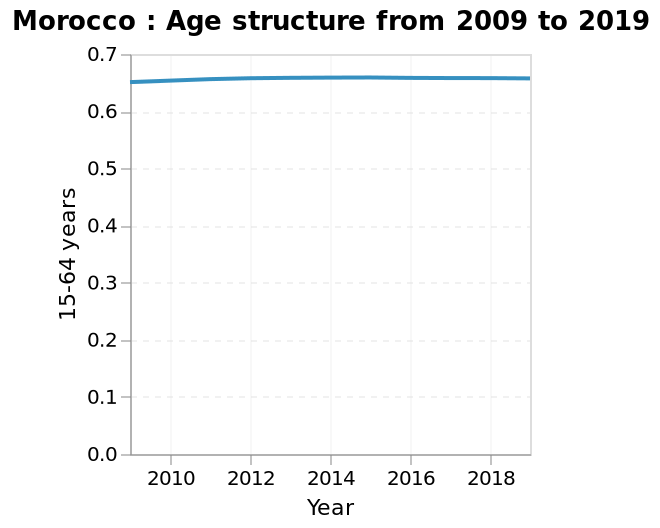<image>
How has the age structure in Morocco changed over time?  The age structure in Morocco has shown little change over the last decade, remaining at approximately 0.65. please summary the statistics and relations of the chart Morocco age structure has remained level in the last decade hovering around 0.65. What is the specific value of the age structure in Morocco?  The age structure in Morocco has been around 0.65 in the last decade. 